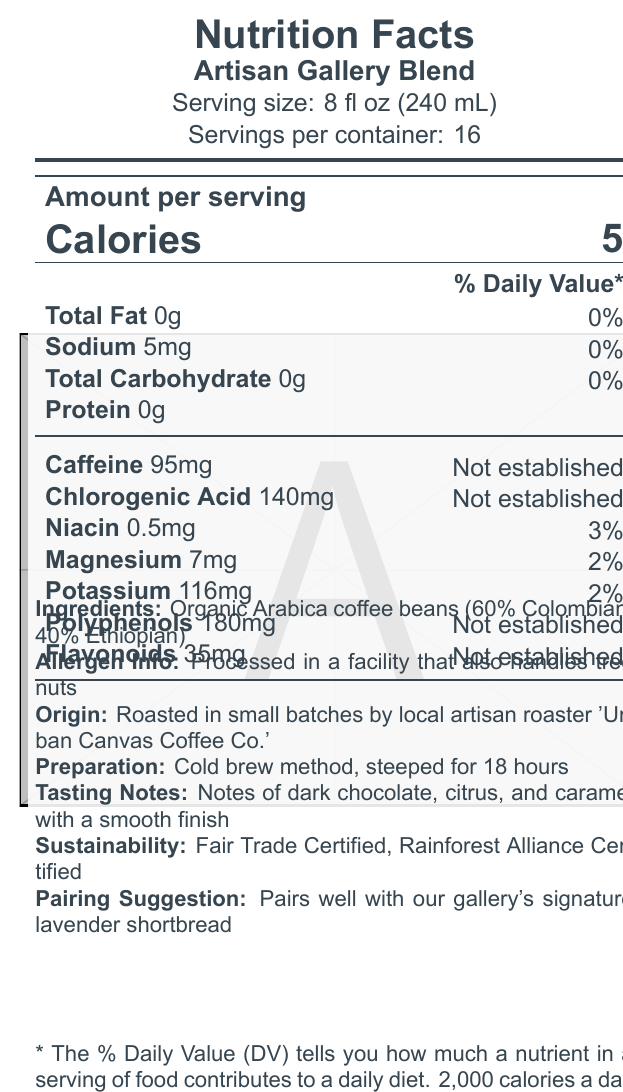What is the serving size of Artisan Gallery Blend? The document states that the serving size of the Artisan Gallery Blend is 8 fl oz (240 mL).
Answer: 8 fl oz (240 mL) How much caffeine is there per serving of the coffee blend? The caffeine content per serving is listed as 95mg in the document.
Answer: 95mg How many calories are in one serving of the Artisan Gallery Blend? The document specifies that there are 5 calories per serving.
Answer: 5 calories Which antioxidant is found in the greatest amount per serving? According to the document, Polyphenols are present in the greatest amount with 180mg per serving.
Answer: Polyphenols What is the daily value percentage for magnesium in one serving of the Artisan Gallery Blend? The document lists the daily value percentage for magnesium as 2%.
Answer: 2% How many servings are there per container of Artisan Gallery Blend? A. 8 B. 10 C. 16 The document states that there are 16 servings per container.
Answer: C. 16 What is the tasting note for this coffee blend? A. Fruity with a hint of berries B. Notes of dark chocolate, citrus, and caramel with a smooth finish C. Earthy with a smoky aftertaste The document describes the tasting notes as "Notes of dark chocolate, citrus, and caramel with a smooth finish".
Answer: B. Notes of dark chocolate, citrus, and caramel with a smooth finish Is the Artisan Gallery Blend Fair Trade Certified? The document mentions that the coffee is Fair Trade Certified under the sustainability section.
Answer: Yes Can you tell if the coffee blend contains any added sugars? The document does not mention added sugars explicitly, so this information cannot be determined.
Answer: Not enough information Summarize the key nutritional information and attributes of the Artisan Gallery Blend. The summary encapsulates the nutritional facts, ingredients, preparation method, sustainability certifications, and pairing suggestions provided in the document.
Answer: The Artisan Gallery Blend has a serving size of 8 fl oz (240 mL) with 16 servings per container. Each serving contains 5 calories, 0g total fat, 5mg sodium (0% DV), 0g total carbohydrate, 0g protein, 95mg caffeine, 140mg chlorogenic acid, 0.5mg niacin (3% DV), 7mg magnesium (2% DV), and 116mg potassium (2% DV). It also includes 180mg polyphenols and 35mg flavonoids as antioxidants. The ingredients are organic Arabica coffee beans (60% Colombian, 40% Ethiopian), and it is prepared using the cold brew method over 18 hours. The coffee blend is Fair Trade Certified and Rainforest Alliance Certified, and it pairs well with lavender shortbread. 